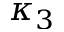<formula> <loc_0><loc_0><loc_500><loc_500>\kappa _ { 3 }</formula> 